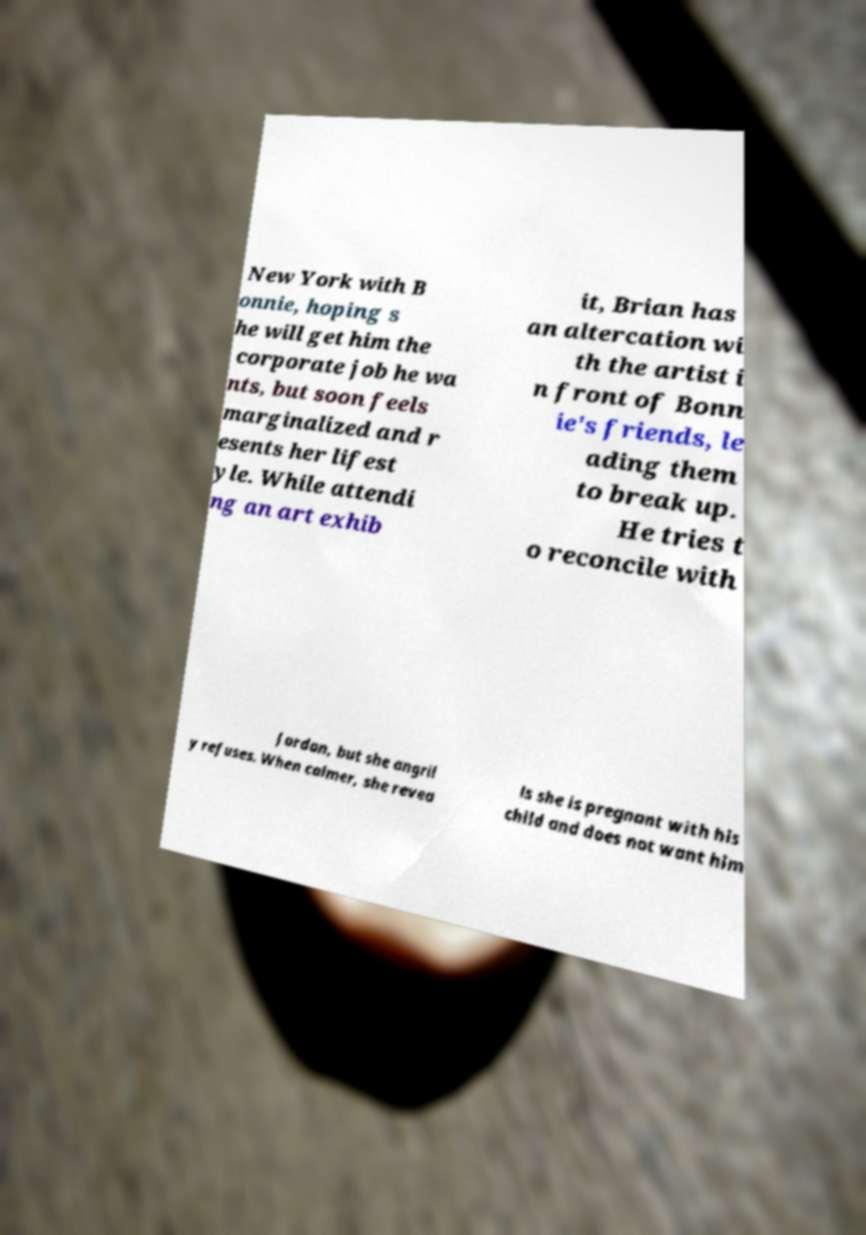There's text embedded in this image that I need extracted. Can you transcribe it verbatim? New York with B onnie, hoping s he will get him the corporate job he wa nts, but soon feels marginalized and r esents her lifest yle. While attendi ng an art exhib it, Brian has an altercation wi th the artist i n front of Bonn ie's friends, le ading them to break up. He tries t o reconcile with Jordan, but she angril y refuses. When calmer, she revea ls she is pregnant with his child and does not want him 